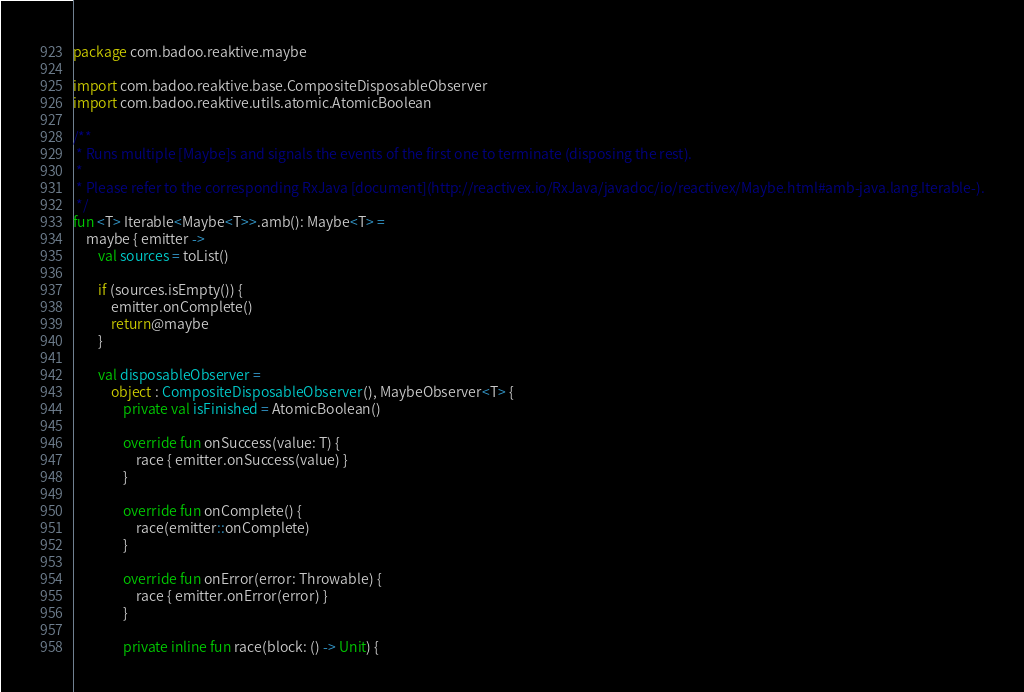<code> <loc_0><loc_0><loc_500><loc_500><_Kotlin_>package com.badoo.reaktive.maybe

import com.badoo.reaktive.base.CompositeDisposableObserver
import com.badoo.reaktive.utils.atomic.AtomicBoolean

/**
 * Runs multiple [Maybe]s and signals the events of the first one to terminate (disposing the rest).
 *
 * Please refer to the corresponding RxJava [document](http://reactivex.io/RxJava/javadoc/io/reactivex/Maybe.html#amb-java.lang.Iterable-).
 */
fun <T> Iterable<Maybe<T>>.amb(): Maybe<T> =
    maybe { emitter ->
        val sources = toList()

        if (sources.isEmpty()) {
            emitter.onComplete()
            return@maybe
        }

        val disposableObserver =
            object : CompositeDisposableObserver(), MaybeObserver<T> {
                private val isFinished = AtomicBoolean()

                override fun onSuccess(value: T) {
                    race { emitter.onSuccess(value) }
                }

                override fun onComplete() {
                    race(emitter::onComplete)
                }

                override fun onError(error: Throwable) {
                    race { emitter.onError(error) }
                }

                private inline fun race(block: () -> Unit) {</code> 